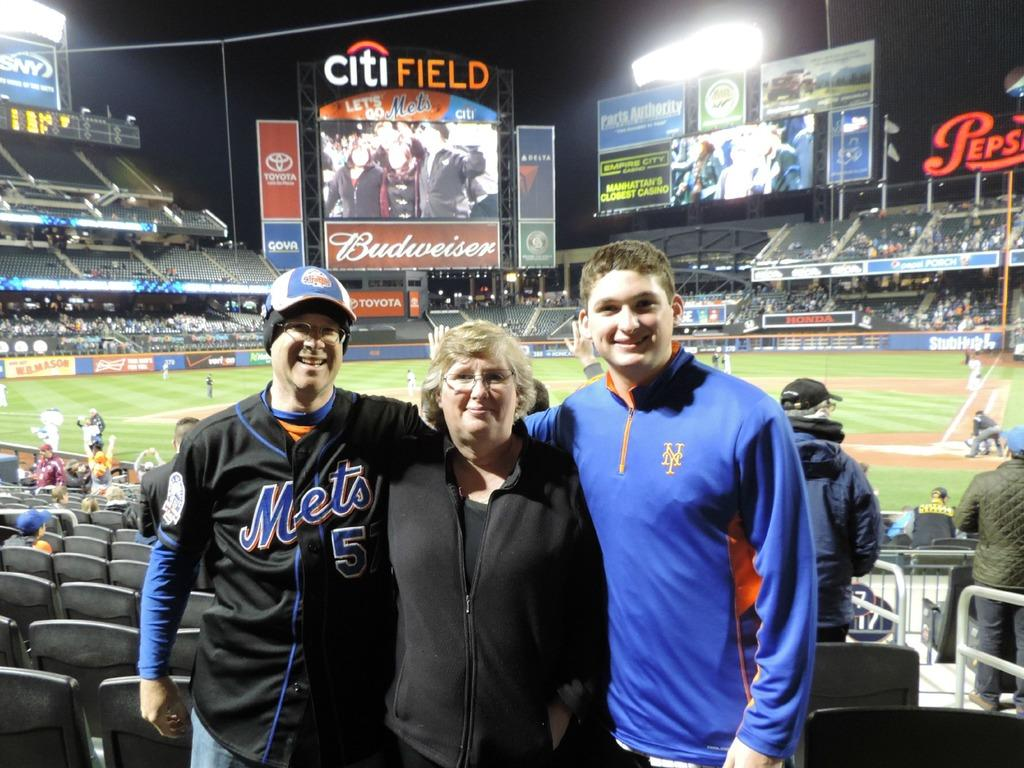<image>
Describe the image concisely. Three people pose with the citi field behind them. 